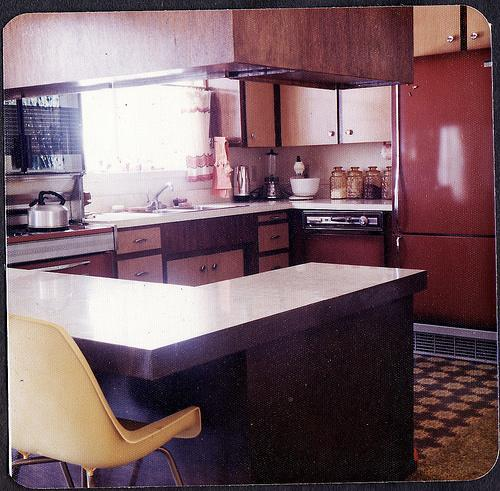What are the jars on the counter? cooking jars 